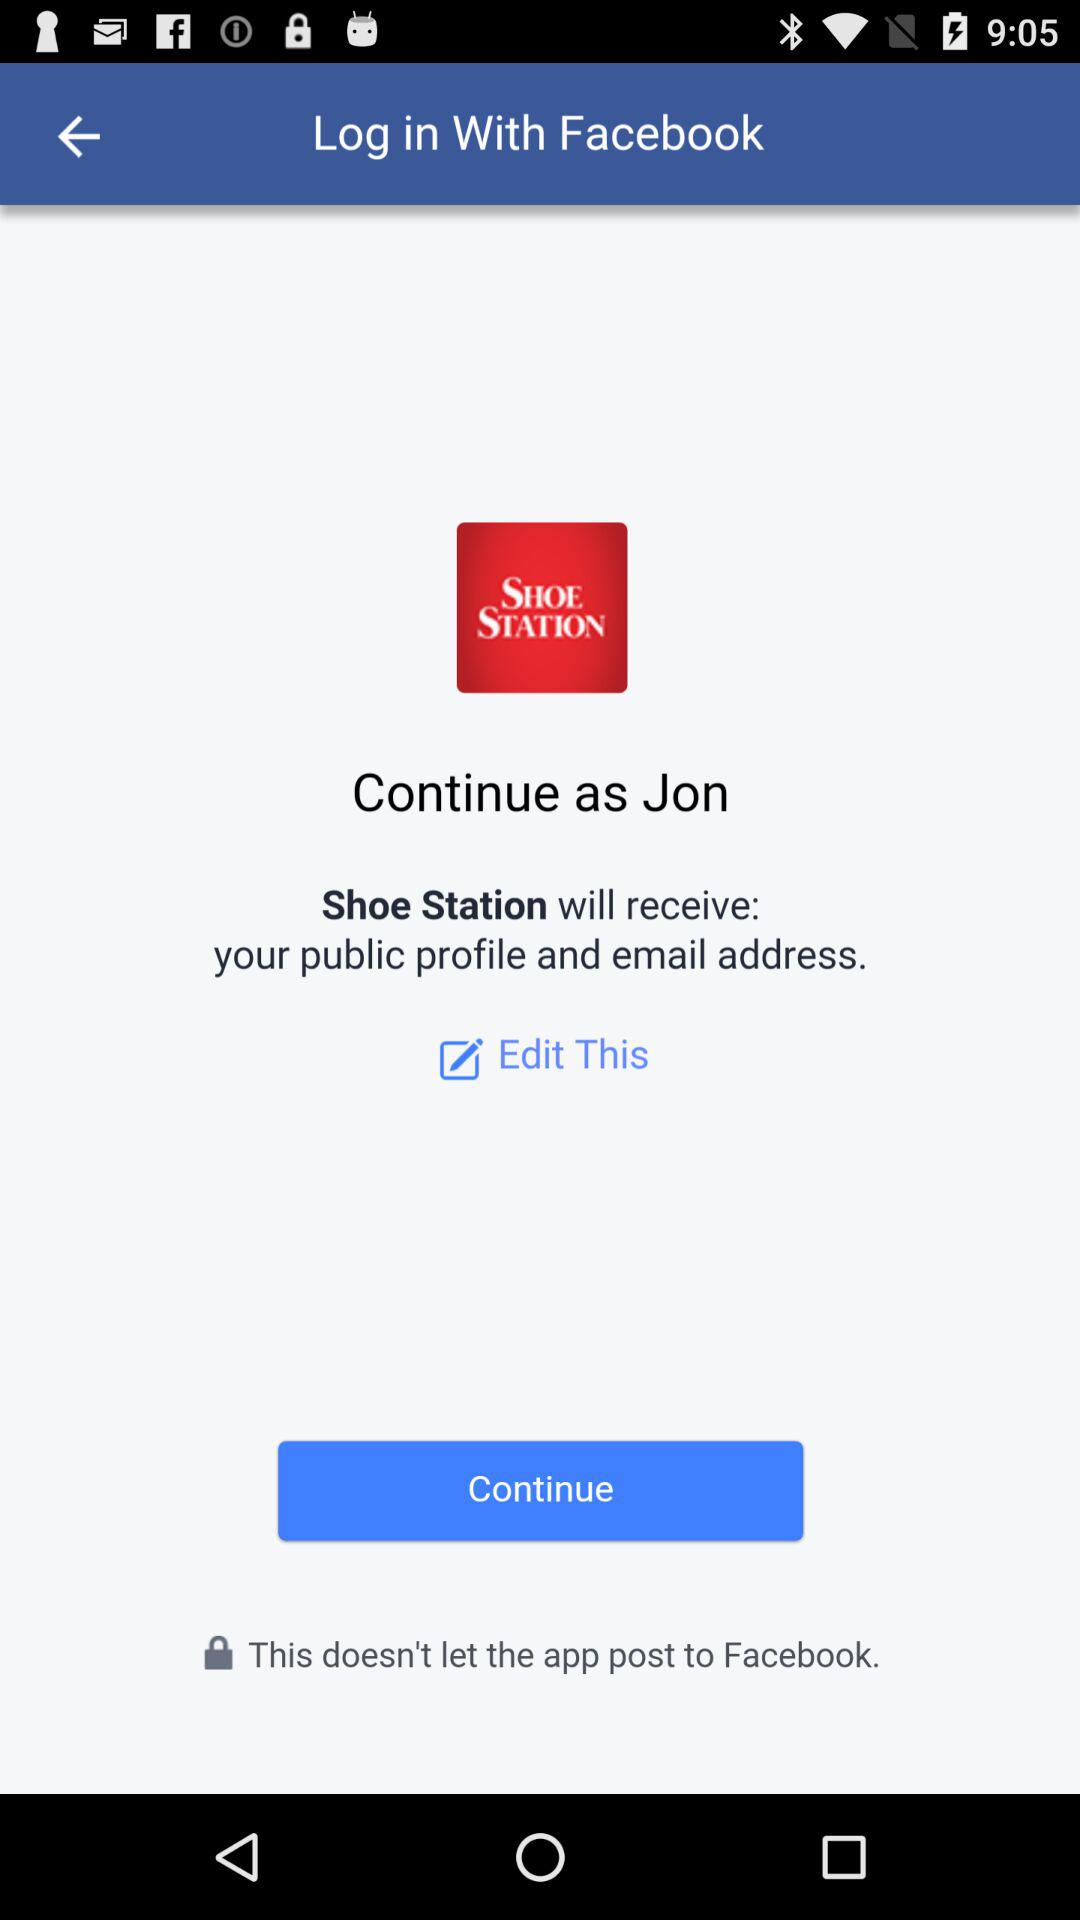Who will receive the public profile and email address? The application "Shoe Station" will receive the public profile and email address. 